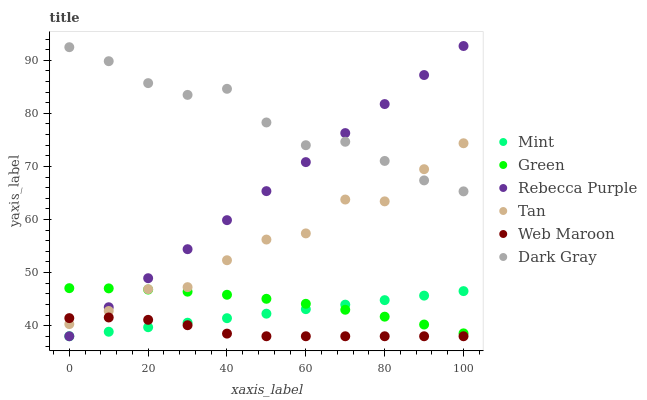Does Web Maroon have the minimum area under the curve?
Answer yes or no. Yes. Does Dark Gray have the maximum area under the curve?
Answer yes or no. Yes. Does Green have the minimum area under the curve?
Answer yes or no. No. Does Green have the maximum area under the curve?
Answer yes or no. No. Is Mint the smoothest?
Answer yes or no. Yes. Is Tan the roughest?
Answer yes or no. Yes. Is Dark Gray the smoothest?
Answer yes or no. No. Is Dark Gray the roughest?
Answer yes or no. No. Does Web Maroon have the lowest value?
Answer yes or no. Yes. Does Green have the lowest value?
Answer yes or no. No. Does Rebecca Purple have the highest value?
Answer yes or no. Yes. Does Dark Gray have the highest value?
Answer yes or no. No. Is Web Maroon less than Dark Gray?
Answer yes or no. Yes. Is Green greater than Web Maroon?
Answer yes or no. Yes. Does Tan intersect Dark Gray?
Answer yes or no. Yes. Is Tan less than Dark Gray?
Answer yes or no. No. Is Tan greater than Dark Gray?
Answer yes or no. No. Does Web Maroon intersect Dark Gray?
Answer yes or no. No. 